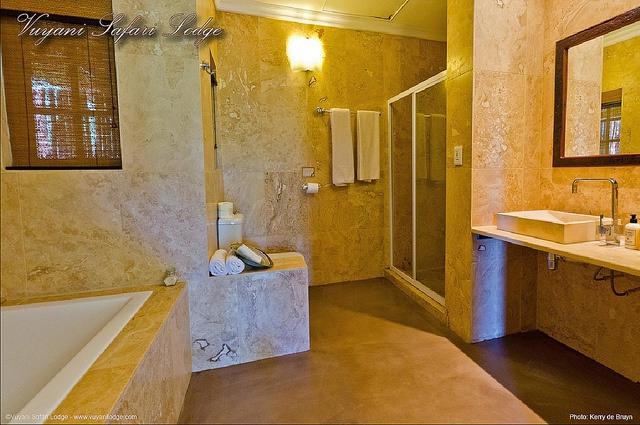Describe the objects in this image and their specific colors. I can see sink in maroon, tan, orange, and olive tones, toilet in maroon, darkgray, tan, and gray tones, and bottle in maroon, tan, orange, olive, and black tones in this image. 